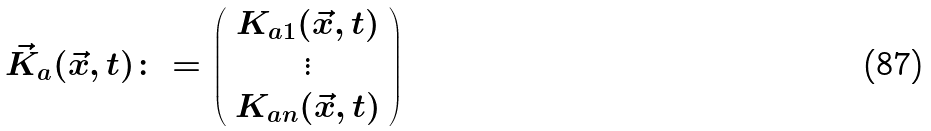Convert formula to latex. <formula><loc_0><loc_0><loc_500><loc_500>\vec { K } _ { a } ( \vec { x } , t ) \colon = \left ( \begin{array} { c } K _ { a 1 } ( \vec { x } , t ) \\ \vdots \\ K _ { a n } ( \vec { x } , t ) \end{array} \right )</formula> 